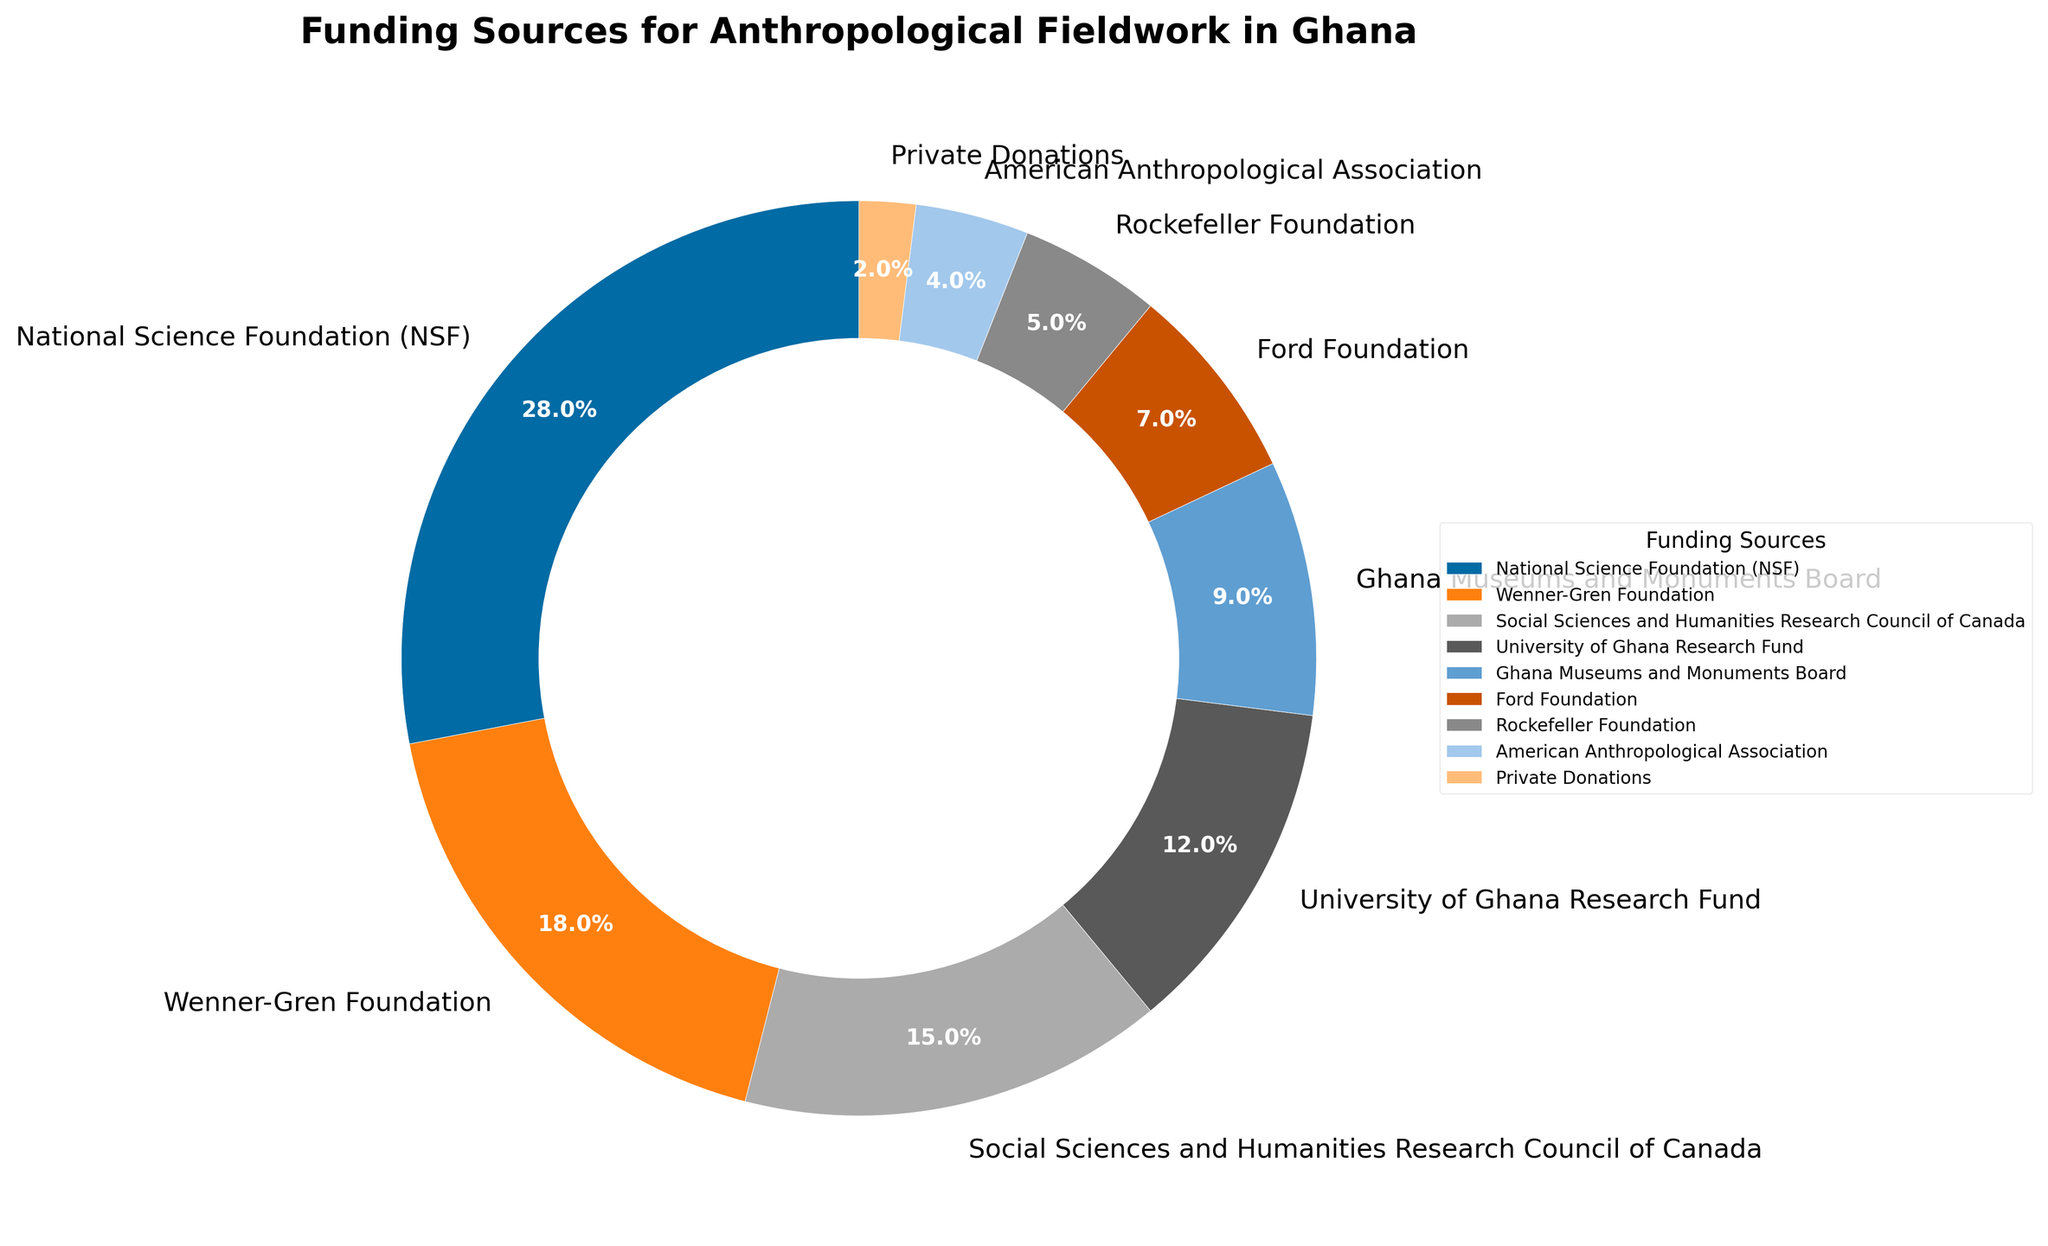What is the combined percentage of funding from the National Science Foundation (NSF) and the Wenner-Gren Foundation? Add the percentage of funding from both sources: NSF (28%) + Wenner-Gren Foundation (18%) = 46%
Answer: 46% Which funding source provides the smallest percentage of funding? The wedge for "Private Donations" is the smallest in the pie chart, indicating it provides the smallest percentage of funding, which is 2%.
Answer: Private Donations Is the percentage of funding from the Ford Foundation greater or less than that from the Ghana Museums and Monuments Board? Compare the two percentages: Ford Foundation (7%) and Ghana Museums and Monuments Board (9%). The Ford Foundation's funding is less.
Answer: Less What is the median percentage of the funding sources? Order the percentages: 2%, 4%, 5%, 7%, 9%, 12%, 15%, 18%, 28%. The median value (middle) in this ordered list is the fifth number, which is 9%.
Answer: 9% Which funding source constitutes more than 25% of the total funding? The only wedge with a percentage greater than 25% is for the National Science Foundation (NSF), which is 28%.
Answer: National Science Foundation (NSF) How much more funding does the National Science Foundation (NSF) contribute compared to the Rockefeller Foundation? Subtract the percentage of the Rockefeller Foundation from the NSF: 28% - 5% = 23%.
Answer: 23% List two funding sources that cumulatively contribute to less than 10% of the funding. Add the smaller percentages to find those summing to less than 10%. Private Donations (2%) + American Anthropological Association (4%) = 6%, which is less than 10%.
Answer: Private Donations, American Anthropological Association Which three sources contribute the most to the funding collectively and what is their combined percentage? Identify the top three contributors: NSF (28%), Wenner-Gren Foundation (18%), Social Sciences and Humanities Research Council of Canada (15%). Sum: 28% + 18% + 15% = 61%
Answer: NSF, Wenner-Gren Foundation, Social Sciences and Humanities Research Council of Canada, 61% If you combine the percentages of the University of Ghana Research Fund and the Ghana Museums and Monuments Board, is their total higher or lower than the Wenner-Gren Foundation? Add the University of Ghana Research Fund (12%) and Ghana Museums and Monuments Board (9%): 12% + 9% = 21%, which is higher than the Wenner-Gren Foundation's 18%.
Answer: Higher 